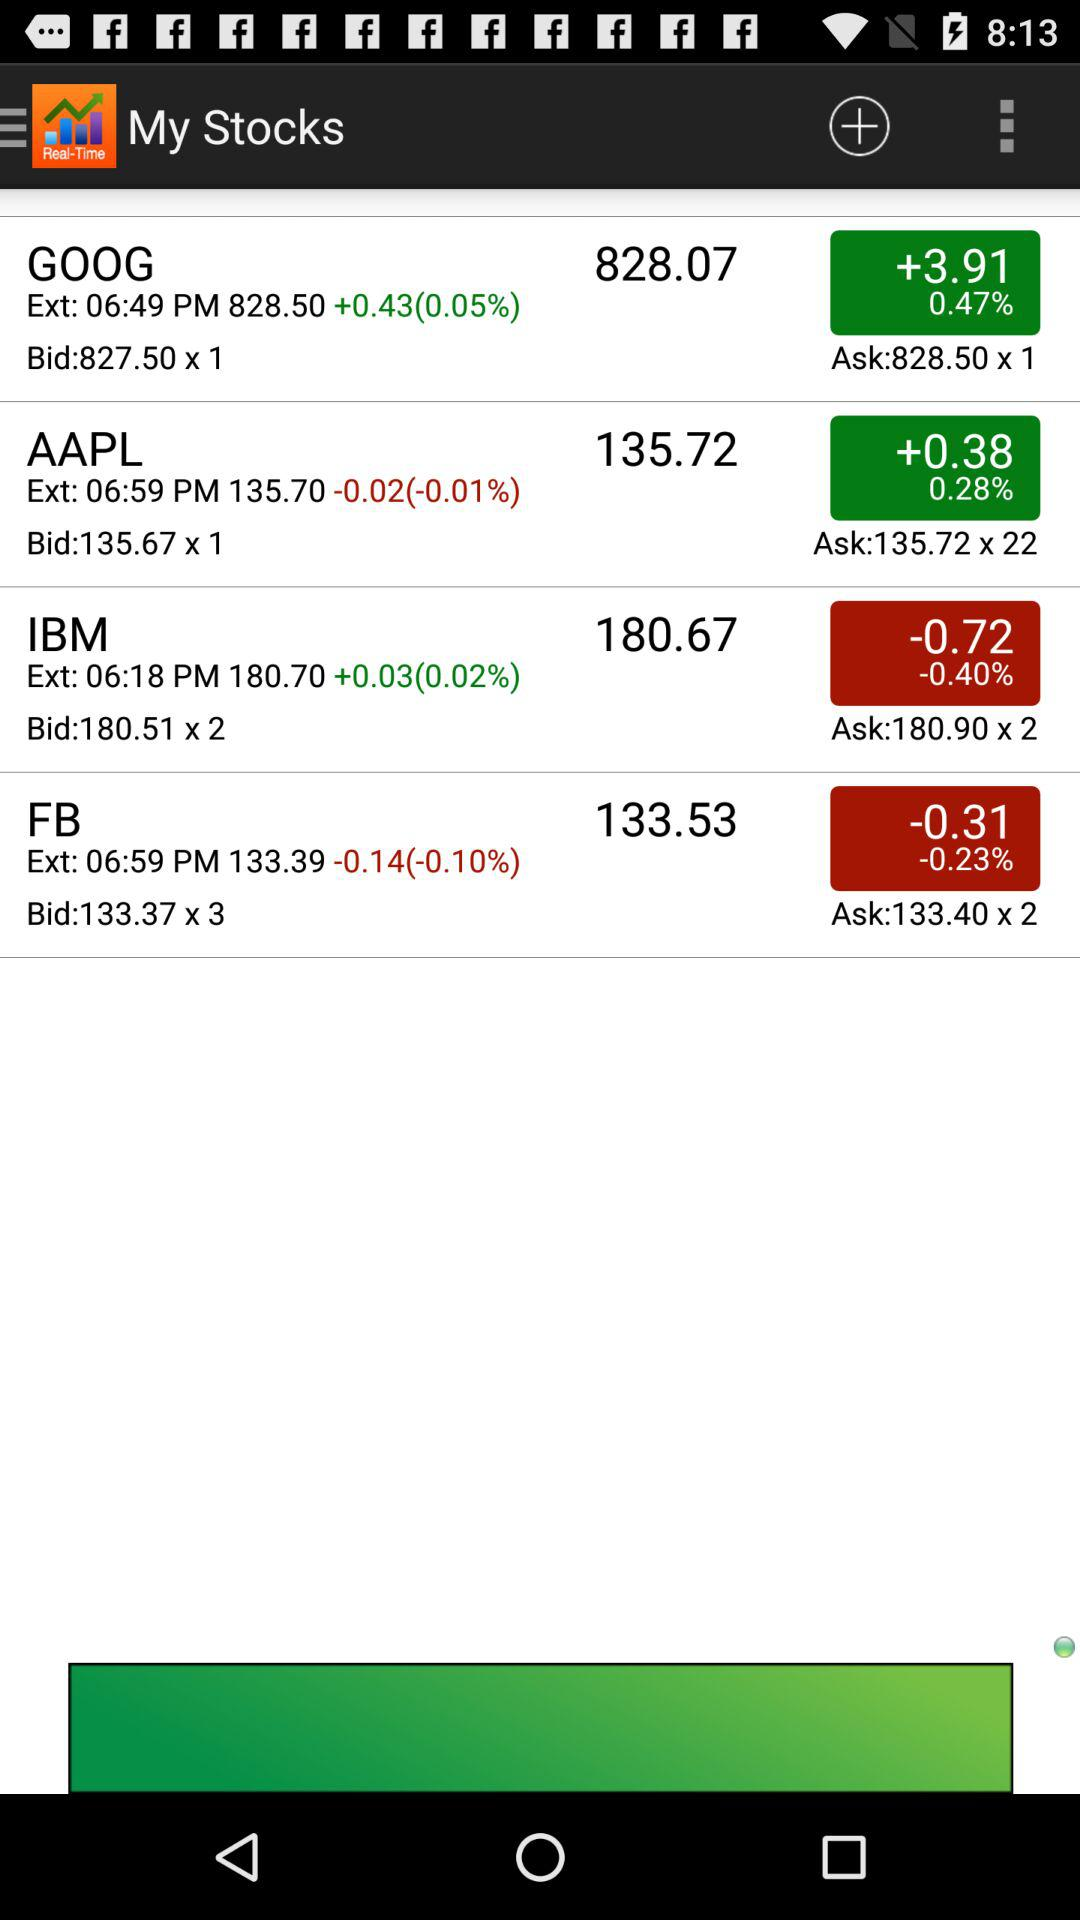Which stock has the highest bid price?
Answer the question using a single word or phrase. GOOG 